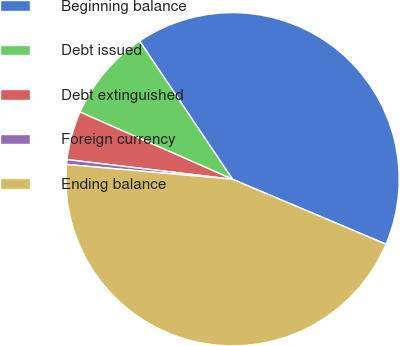<chart> <loc_0><loc_0><loc_500><loc_500><pie_chart><fcel>Beginning balance<fcel>Debt issued<fcel>Debt extinguished<fcel>Foreign currency<fcel>Ending balance<nl><fcel>40.79%<fcel>8.97%<fcel>4.72%<fcel>0.47%<fcel>45.04%<nl></chart> 